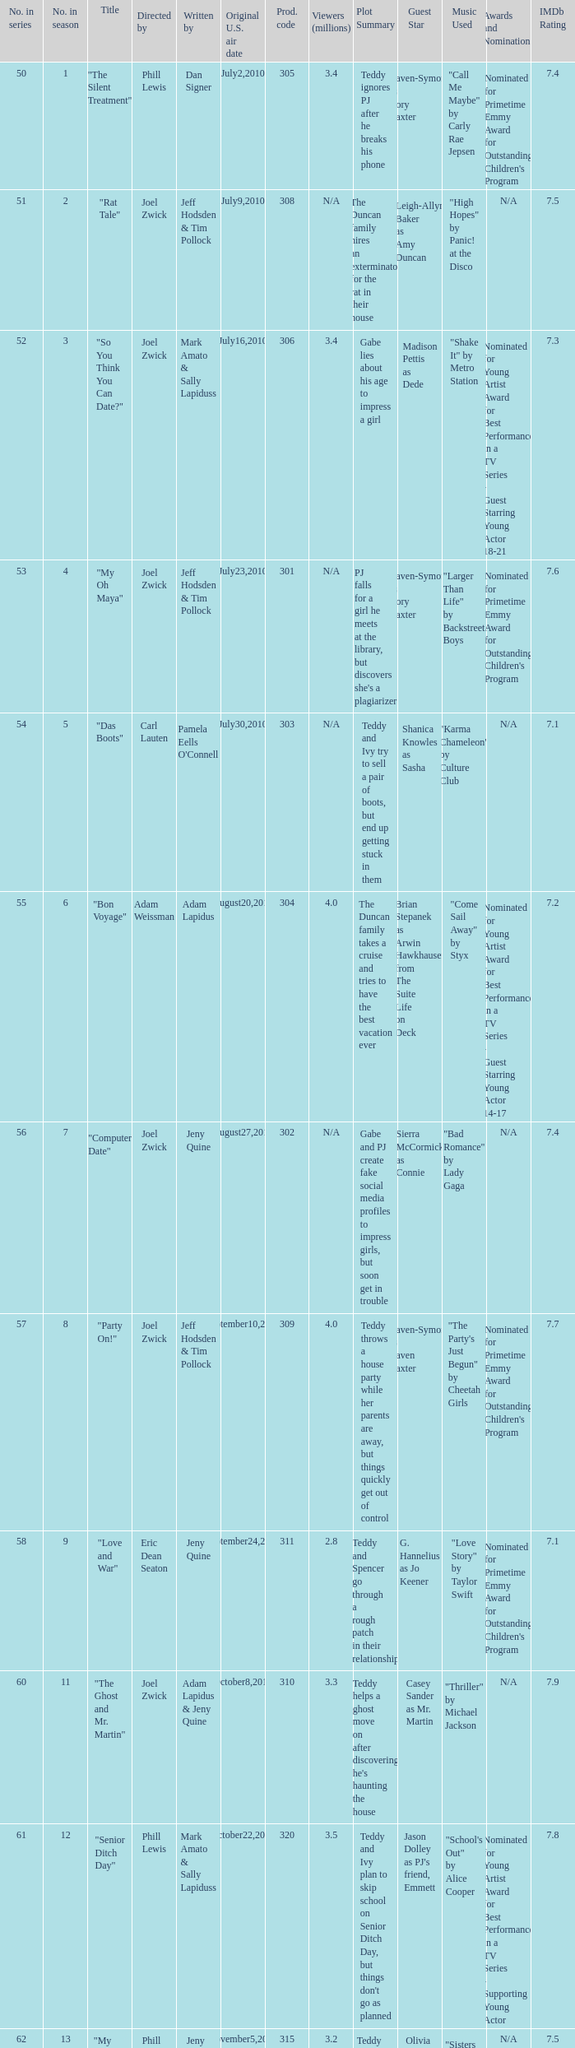Which us broadcast date had January14,2011. 